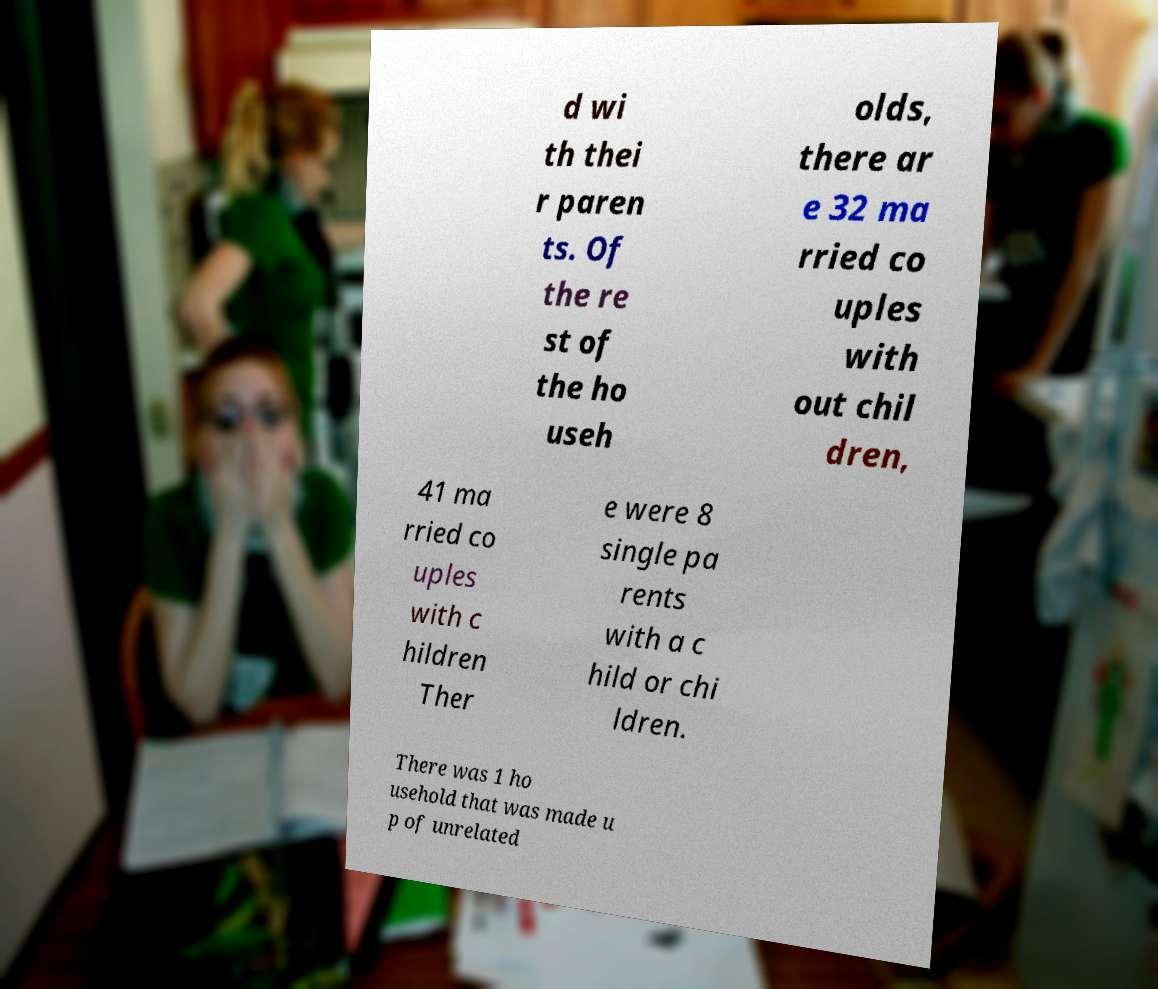Please read and relay the text visible in this image. What does it say? d wi th thei r paren ts. Of the re st of the ho useh olds, there ar e 32 ma rried co uples with out chil dren, 41 ma rried co uples with c hildren Ther e were 8 single pa rents with a c hild or chi ldren. There was 1 ho usehold that was made u p of unrelated 